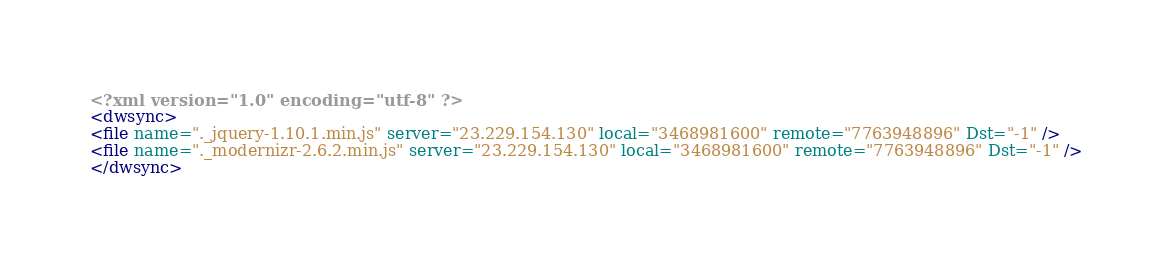<code> <loc_0><loc_0><loc_500><loc_500><_XML_><?xml version="1.0" encoding="utf-8" ?><dwsync><file name="._jquery-1.10.1.min.js" server="23.229.154.130" local="3468981600" remote="7763948896" Dst="-1" /><file name="._modernizr-2.6.2.min.js" server="23.229.154.130" local="3468981600" remote="7763948896" Dst="-1" /></dwsync></code> 